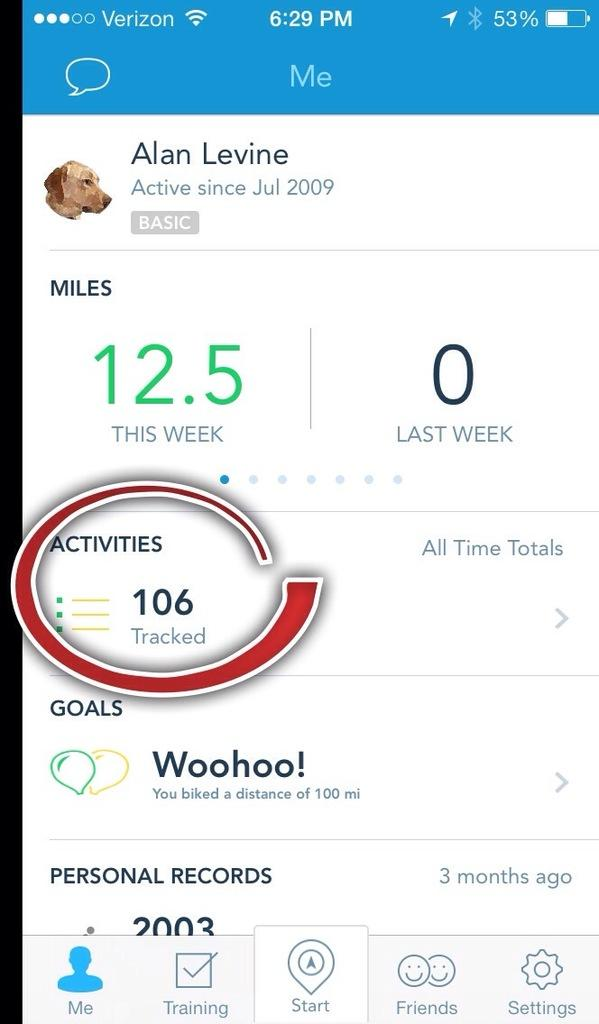Provide a one-sentence caption for the provided image. A person's miles and activity tracked on a personal app on their phone. 